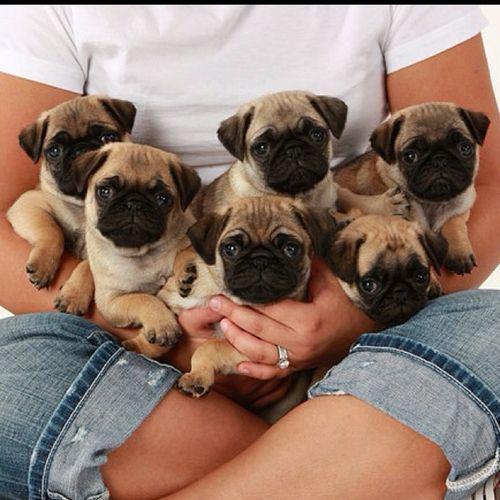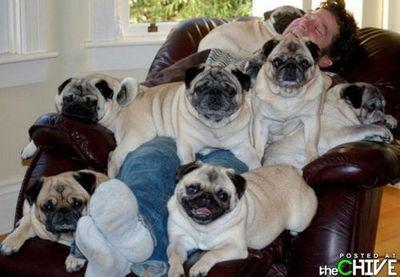The first image is the image on the left, the second image is the image on the right. Analyze the images presented: Is the assertion "There are less than 5 dogs in the left image." valid? Answer yes or no. No. 